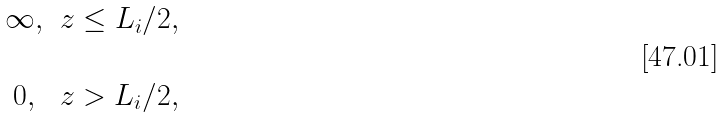Convert formula to latex. <formula><loc_0><loc_0><loc_500><loc_500>\begin{matrix} \infty , & z \leq L _ { i } / 2 , \\ \\ 0 , & z > L _ { i } / 2 , \end{matrix}</formula> 